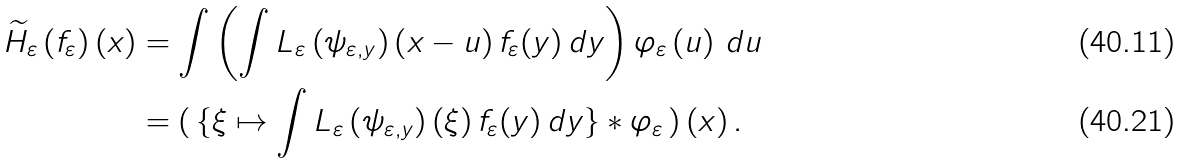Convert formula to latex. <formula><loc_0><loc_0><loc_500><loc_500>\widetilde { H } _ { \varepsilon } \left ( f _ { \varepsilon } \right ) \left ( x \right ) & = \int \left ( \int L _ { \varepsilon } \left ( \psi _ { \varepsilon , y } \right ) \left ( x - u \right ) f _ { \varepsilon } ( y ) \, d y \right ) \varphi _ { \varepsilon } \left ( u \right ) \, d u \\ & = ( \, \{ \xi \mapsto \int L _ { \varepsilon } \left ( \psi _ { \varepsilon , y } \right ) \left ( \xi \right ) f _ { \varepsilon } ( y ) \, d y \} \ast \varphi _ { \varepsilon } \, ) \left ( x \right ) .</formula> 